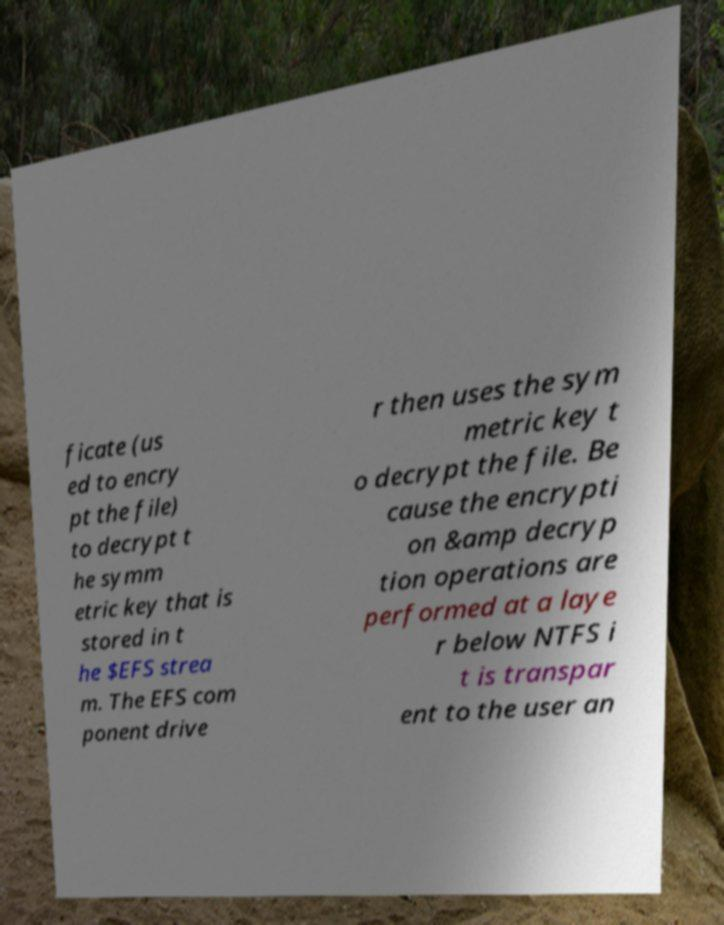Could you extract and type out the text from this image? ficate (us ed to encry pt the file) to decrypt t he symm etric key that is stored in t he $EFS strea m. The EFS com ponent drive r then uses the sym metric key t o decrypt the file. Be cause the encrypti on &amp decryp tion operations are performed at a laye r below NTFS i t is transpar ent to the user an 